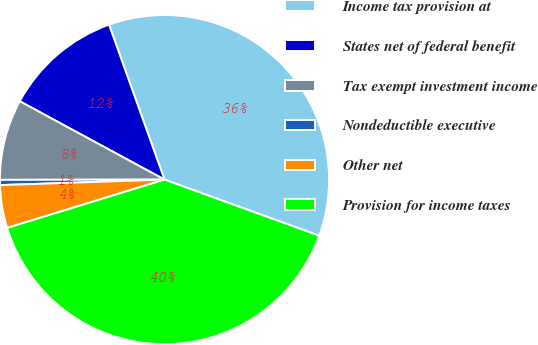Convert chart to OTSL. <chart><loc_0><loc_0><loc_500><loc_500><pie_chart><fcel>Income tax provision at<fcel>States net of federal benefit<fcel>Tax exempt investment income<fcel>Nondeductible executive<fcel>Other net<fcel>Provision for income taxes<nl><fcel>36.01%<fcel>11.63%<fcel>7.92%<fcel>0.51%<fcel>4.21%<fcel>39.72%<nl></chart> 